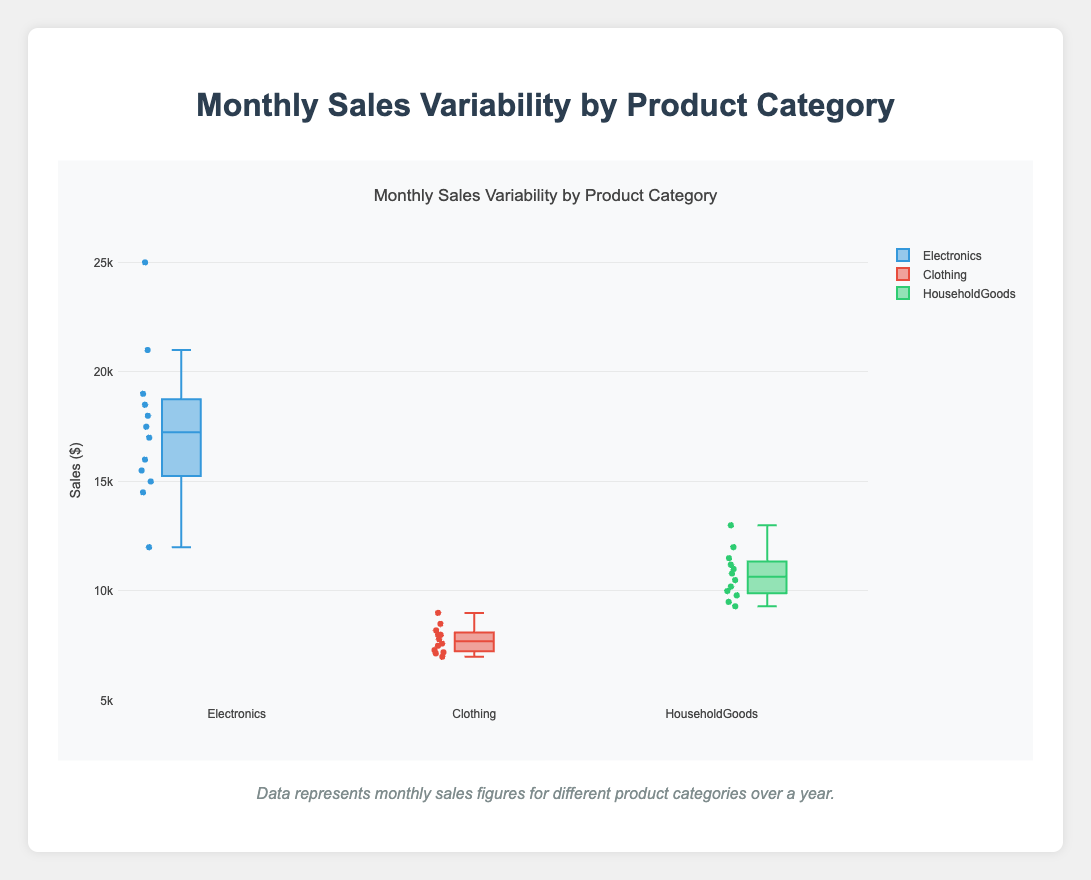What's the title of the figure? The title is usually located at the top of the figure and provides an overview of what the chart is about. Here, the title reads "Monthly Sales Variability by Product Category."
Answer: Monthly Sales Variability by Product Category What does the y-axis represent? The y-axis typically represents the variable being measured. In this figure, the y-axis title indicates it represents "Sales ($)."
Answer: Sales ($) Which product category has the highest median sales? To find the median, look at the middle line in each box. For Electronics, the median is around 17000; for Clothing, it's around 8000; and for Household Goods, it's around 11000. Therefore, Electronics has the highest median.
Answer: Electronics What is the range of sales for the Clothing category? The range can be found by identifying the minimum and maximum points in the box plot. For Clothing, the sales range from about 7000 to 9000.
Answer: 7000 to 9000 Which product category shows the least variability in sales? Variability in a box plot is often represented by the interquartile range (IQR). The Clothing category has the smallest IQR since the box is the smallest height-wise.
Answer: Clothing How do the November sales compare across the three product categories? By examining the data points: November sales for Electronics are 21000, for Clothing are 8500, and for Household Goods are 12000. Electronics has the highest, followed by Household Goods and Clothing.
Answer: Electronics > Household Goods > Clothing What is the interquartile range (IQR) for Household Goods sales? The IQR is the range between the first quartile (Q1) and the third quartile (Q3). For Household Goods, Q1 is around 9500 and Q3 is around 12000. Subtracting these gives an IQR of 2500.
Answer: 2500 Which product category has outliers, and what do they represent? Outliers are points that are significantly distant from the rest. In the Electronics category, December (25000) stands out as an outlier, indicating extremely high sales that month.
Answer: Electronics What month shows the highest sales for Electronics? For the Electronics category, the highest sales point is in December, where the value reaches up to 25000.
Answer: December What's the difference in median sales between Electronics and Clothing? The median sales for Electronics are around 17000 and for Clothing around 8000, making the difference 17000 - 8000.
Answer: 9000 